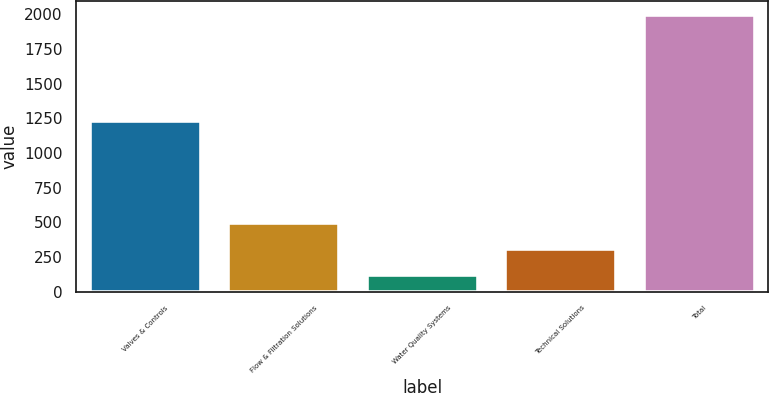Convert chart. <chart><loc_0><loc_0><loc_500><loc_500><bar_chart><fcel>Valves & Controls<fcel>Flow & Filtration Solutions<fcel>Water Quality Systems<fcel>Technical Solutions<fcel>Total<nl><fcel>1233.7<fcel>496.18<fcel>121<fcel>308.59<fcel>1996.9<nl></chart> 